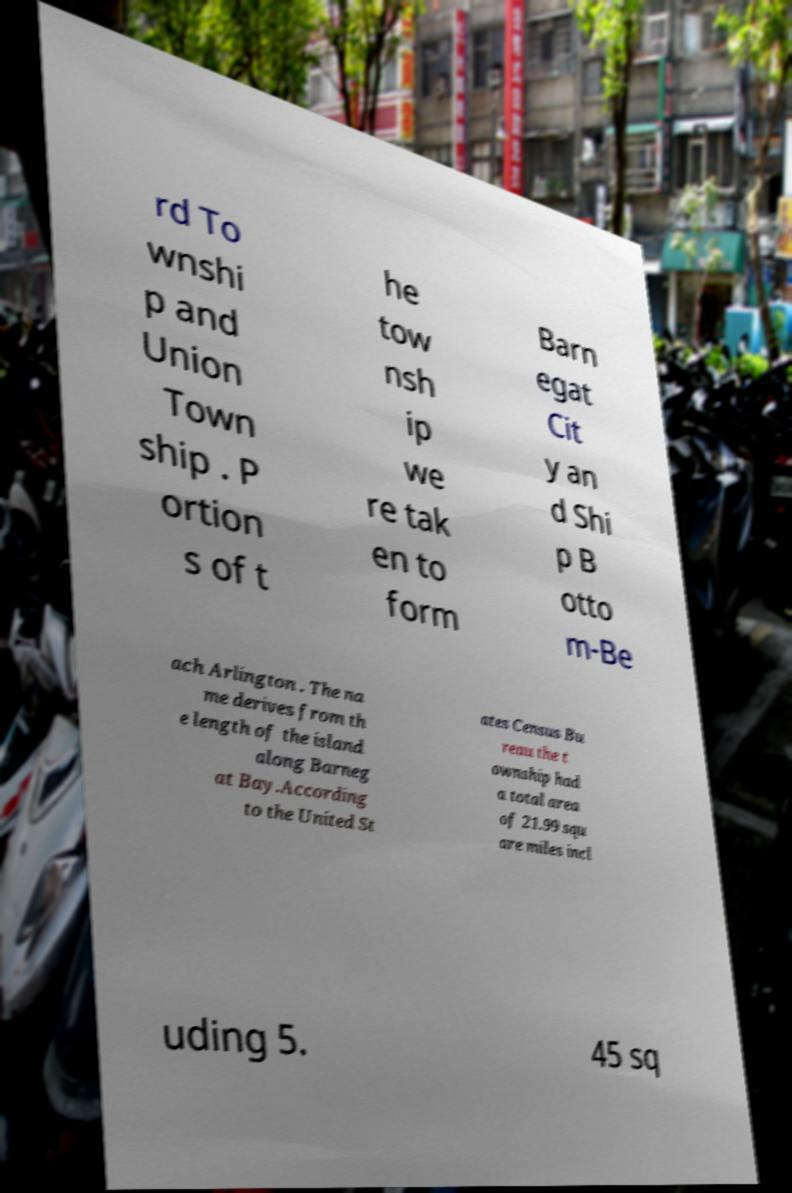Can you accurately transcribe the text from the provided image for me? rd To wnshi p and Union Town ship . P ortion s of t he tow nsh ip we re tak en to form Barn egat Cit y an d Shi p B otto m-Be ach Arlington . The na me derives from th e length of the island along Barneg at Bay.According to the United St ates Census Bu reau the t ownship had a total area of 21.99 squ are miles incl uding 5. 45 sq 